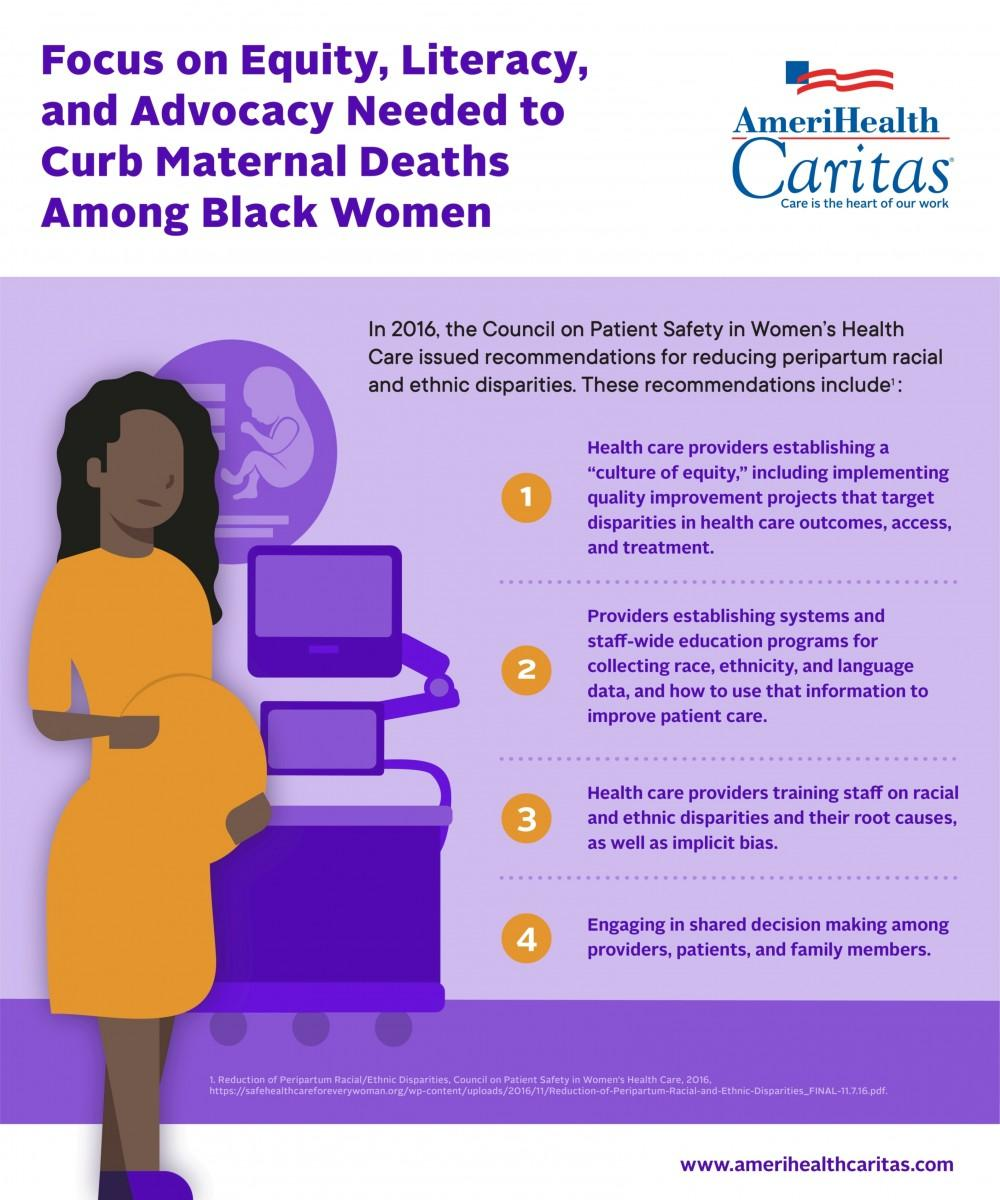Highlight a few significant elements in this photo. Four recommendations were provided to address peripartum racial and ethnic disparities. 